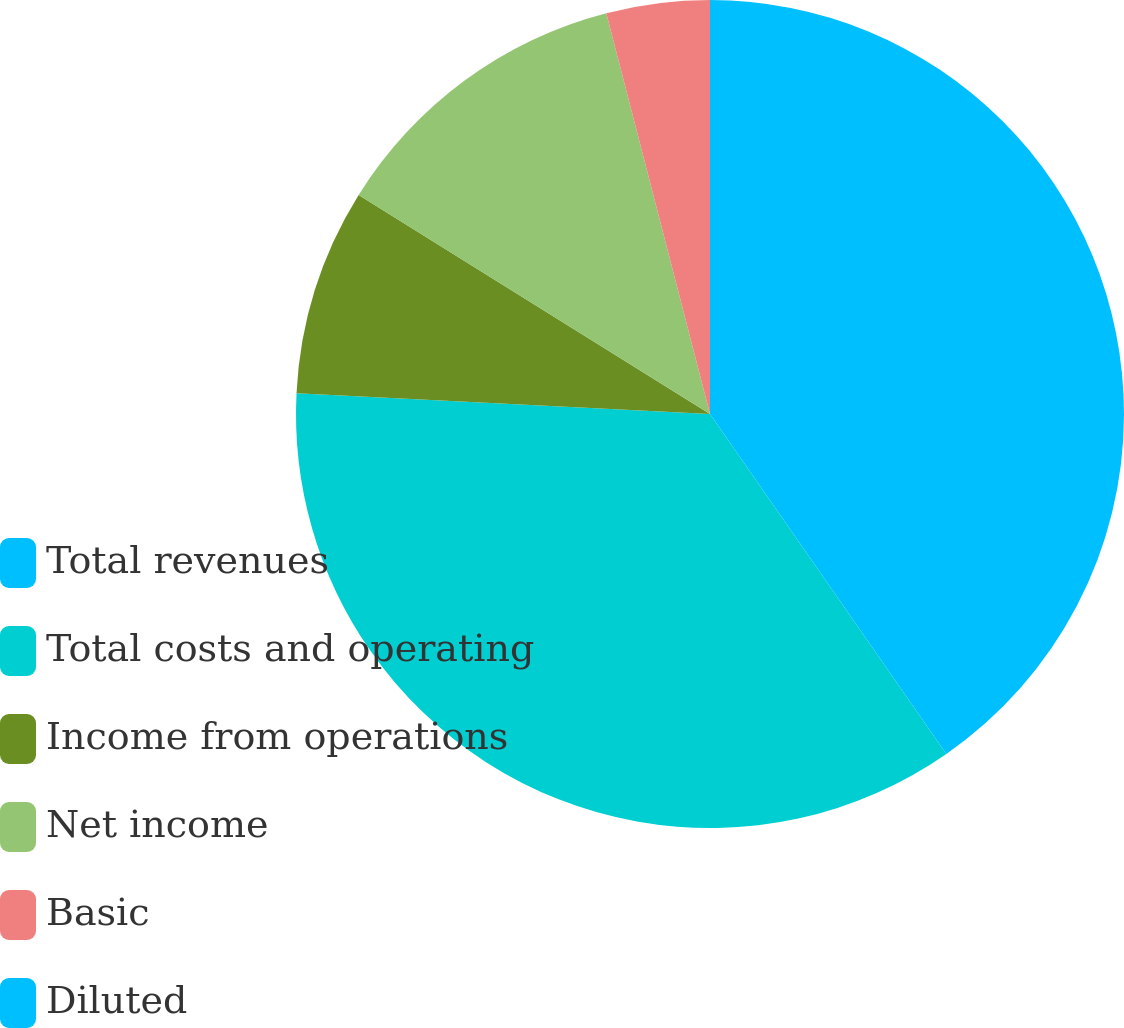<chart> <loc_0><loc_0><loc_500><loc_500><pie_chart><fcel>Total revenues<fcel>Total costs and operating<fcel>Income from operations<fcel>Net income<fcel>Basic<fcel>Diluted<nl><fcel>40.33%<fcel>35.47%<fcel>8.07%<fcel>12.1%<fcel>4.03%<fcel>0.0%<nl></chart> 